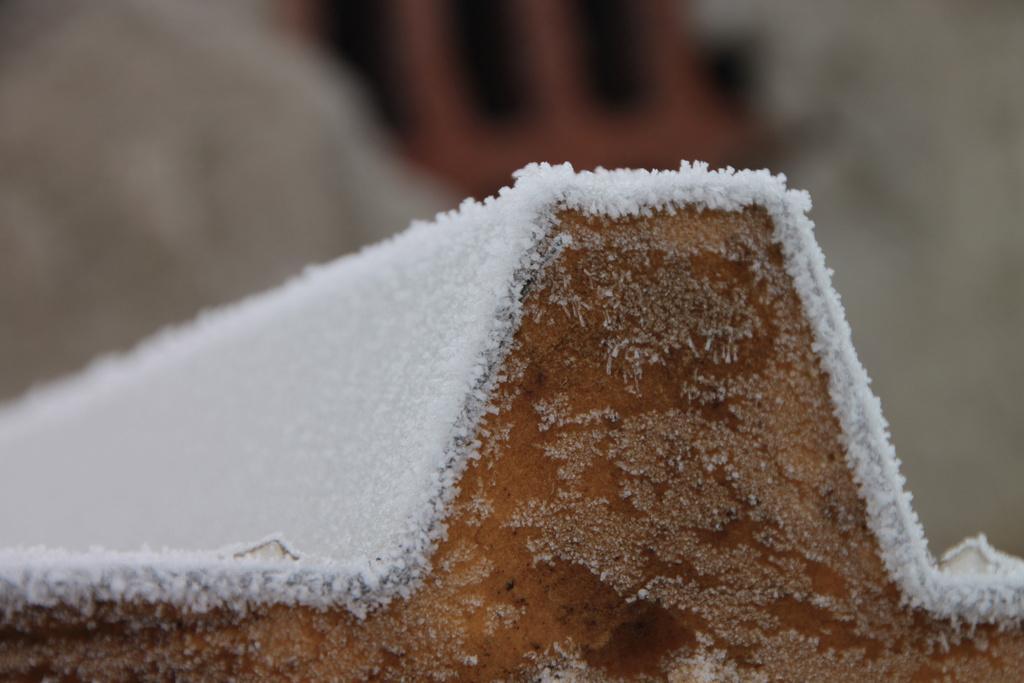Can you describe this image briefly? In this image we can see an object and there is a white color layer on it. There is a blur background in the image. 